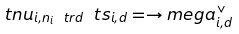Convert formula to latex. <formula><loc_0><loc_0><loc_500><loc_500>\ t n u _ { i , n _ { i } \ t r d } \ t s _ { i , d } = \to m e g a ^ { \vee } _ { i , d }</formula> 